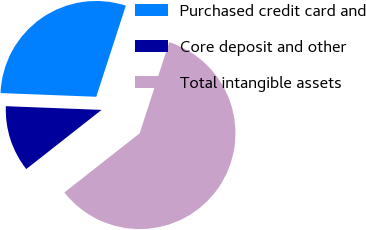<chart> <loc_0><loc_0><loc_500><loc_500><pie_chart><fcel>Purchased credit card and<fcel>Core deposit and other<fcel>Total intangible assets<nl><fcel>29.38%<fcel>11.22%<fcel>59.4%<nl></chart> 